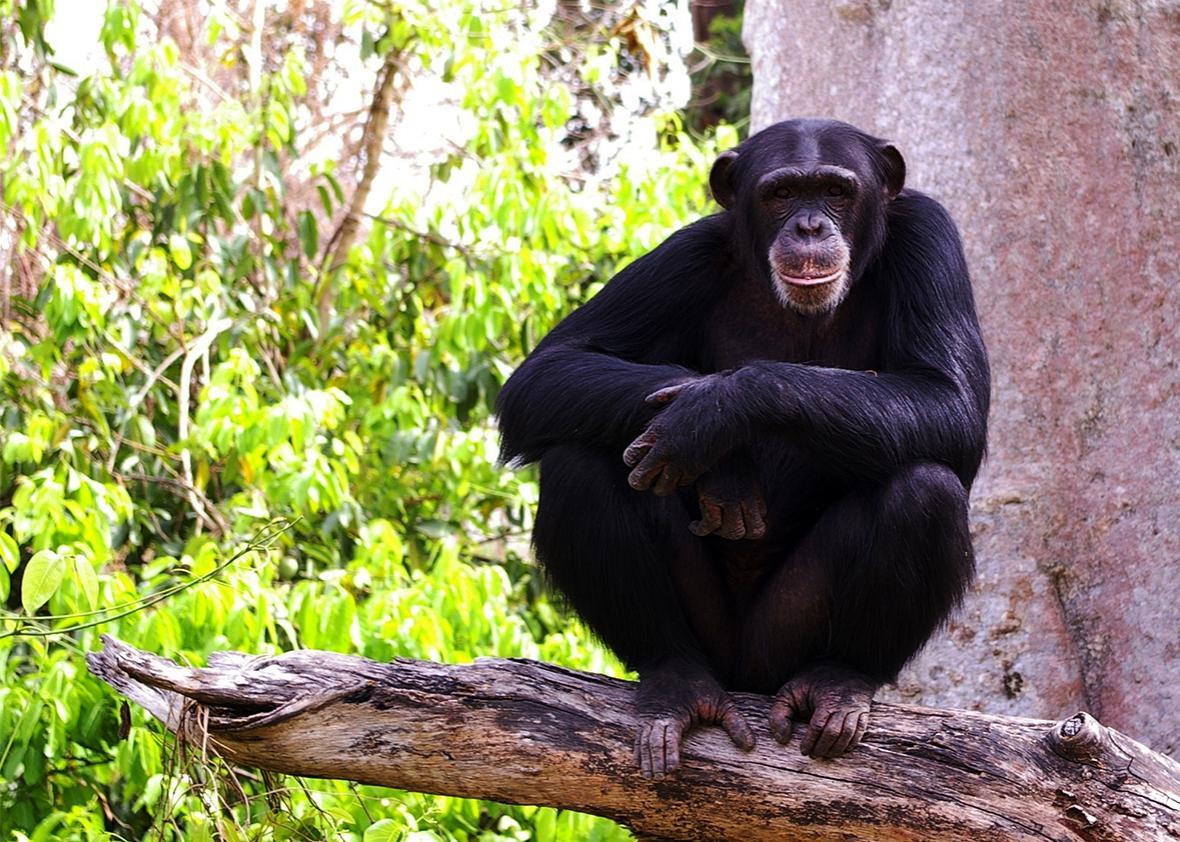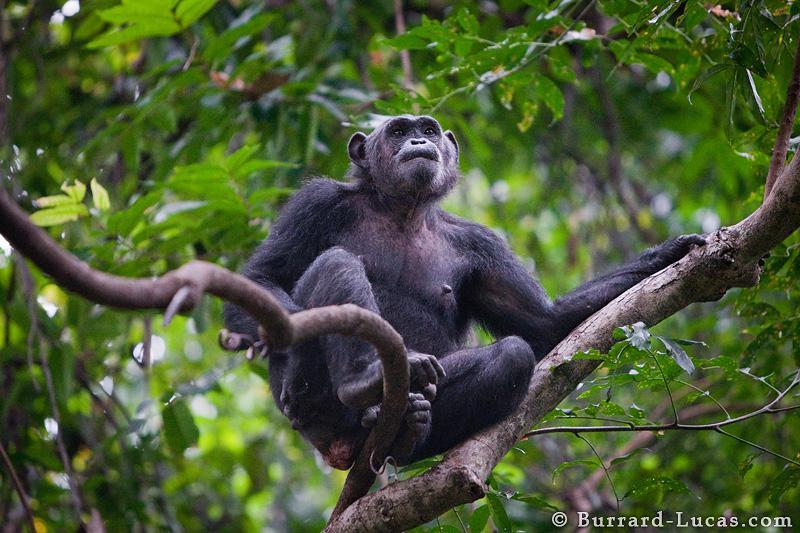The first image is the image on the left, the second image is the image on the right. Given the left and right images, does the statement "At least one chimp is squatting on a somewhat horizontal branch, surrounded by foliage." hold true? Answer yes or no. Yes. The first image is the image on the left, the second image is the image on the right. Analyze the images presented: Is the assertion "There are chimpanzees sitting on a suspended tree branch." valid? Answer yes or no. Yes. 